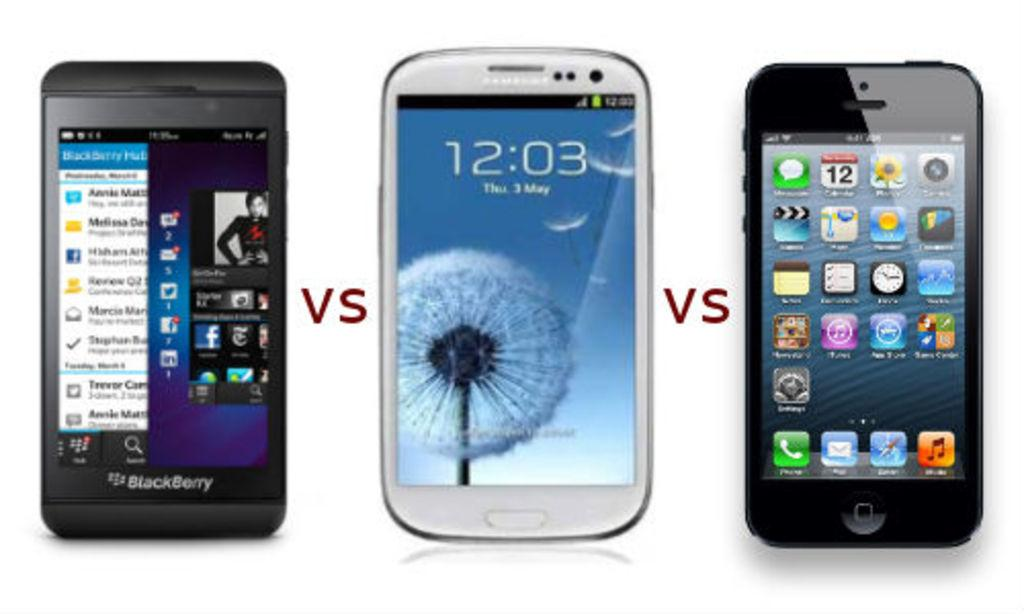Provide a one-sentence caption for the provided image. Three different brands of smart phones with VS between each of them. 